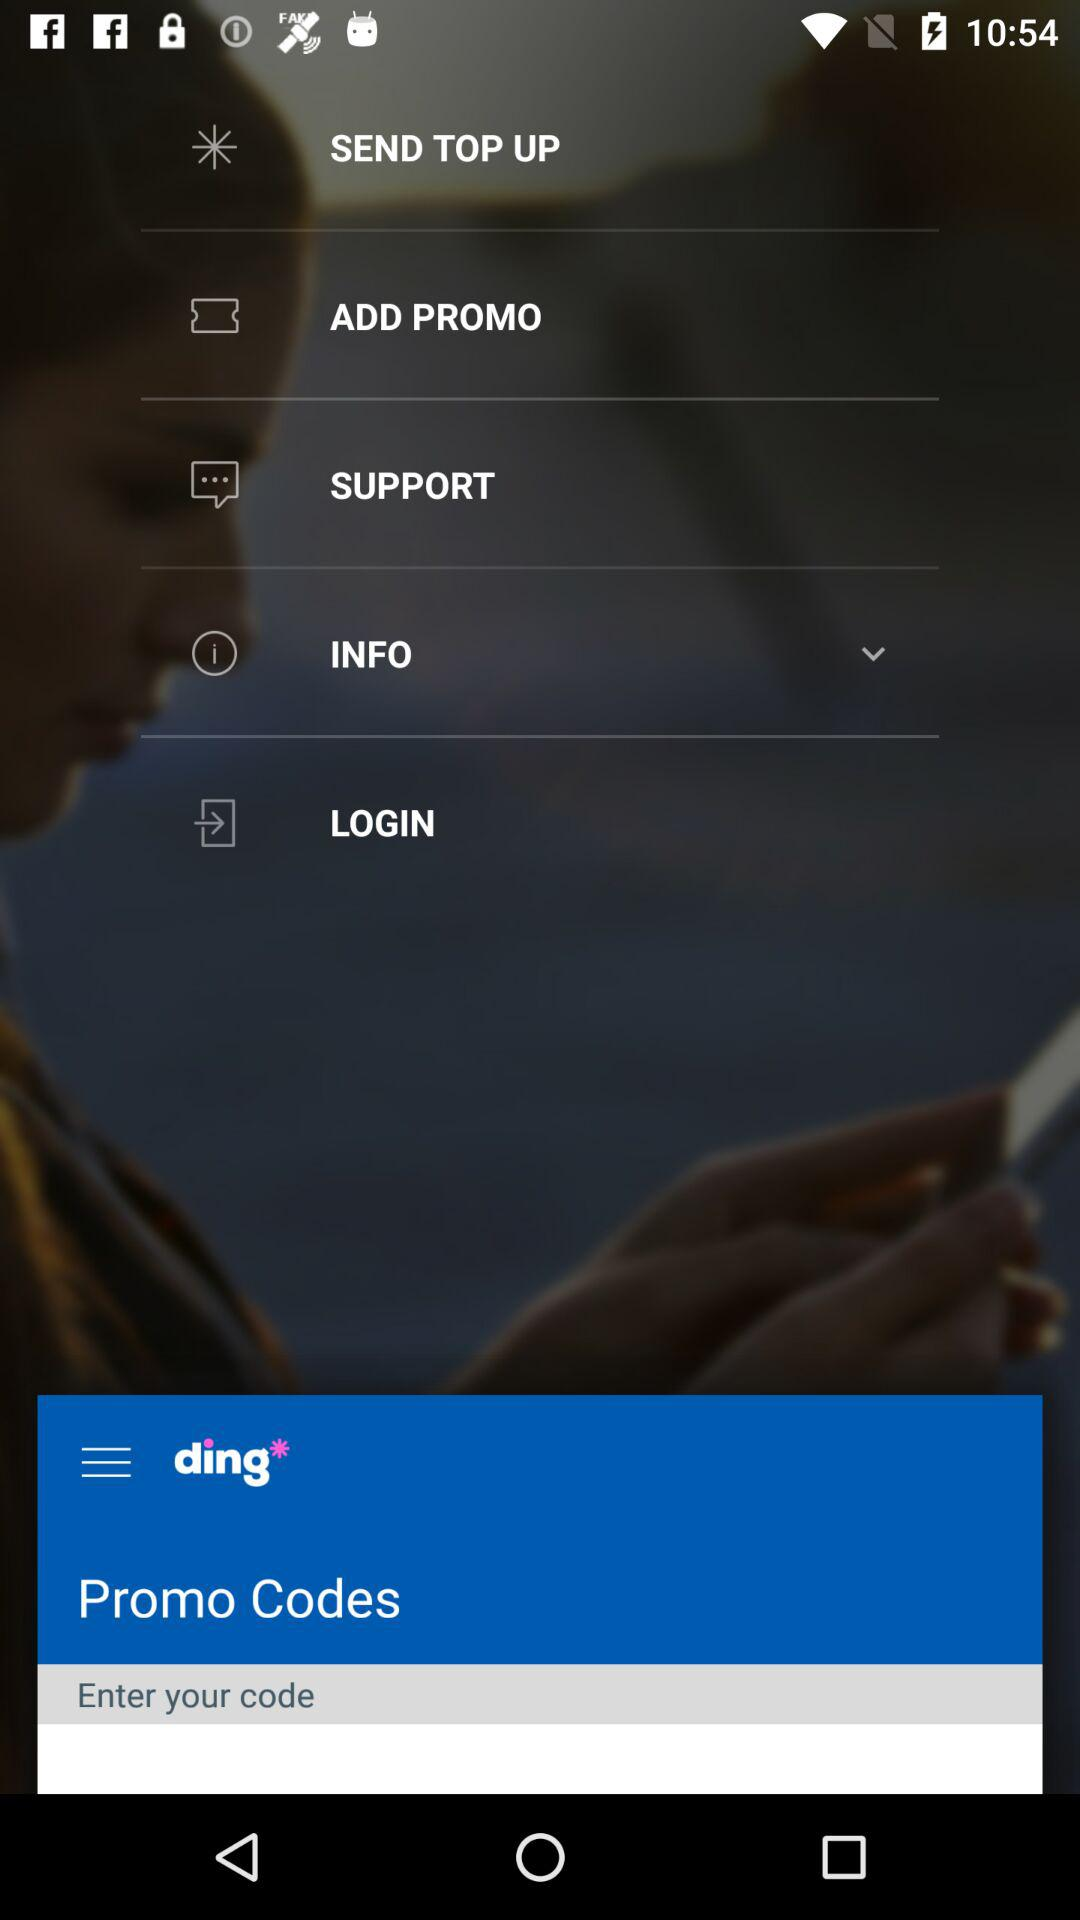What is the name of the application? The name of the application is "ding". 